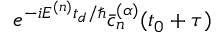Convert formula to latex. <formula><loc_0><loc_0><loc_500><loc_500>e ^ { - i E ^ { ( n ) } t _ { d } / } \ B a r { c } _ { n } ^ { ( \alpha ) } ( t _ { 0 } + \tau )</formula> 